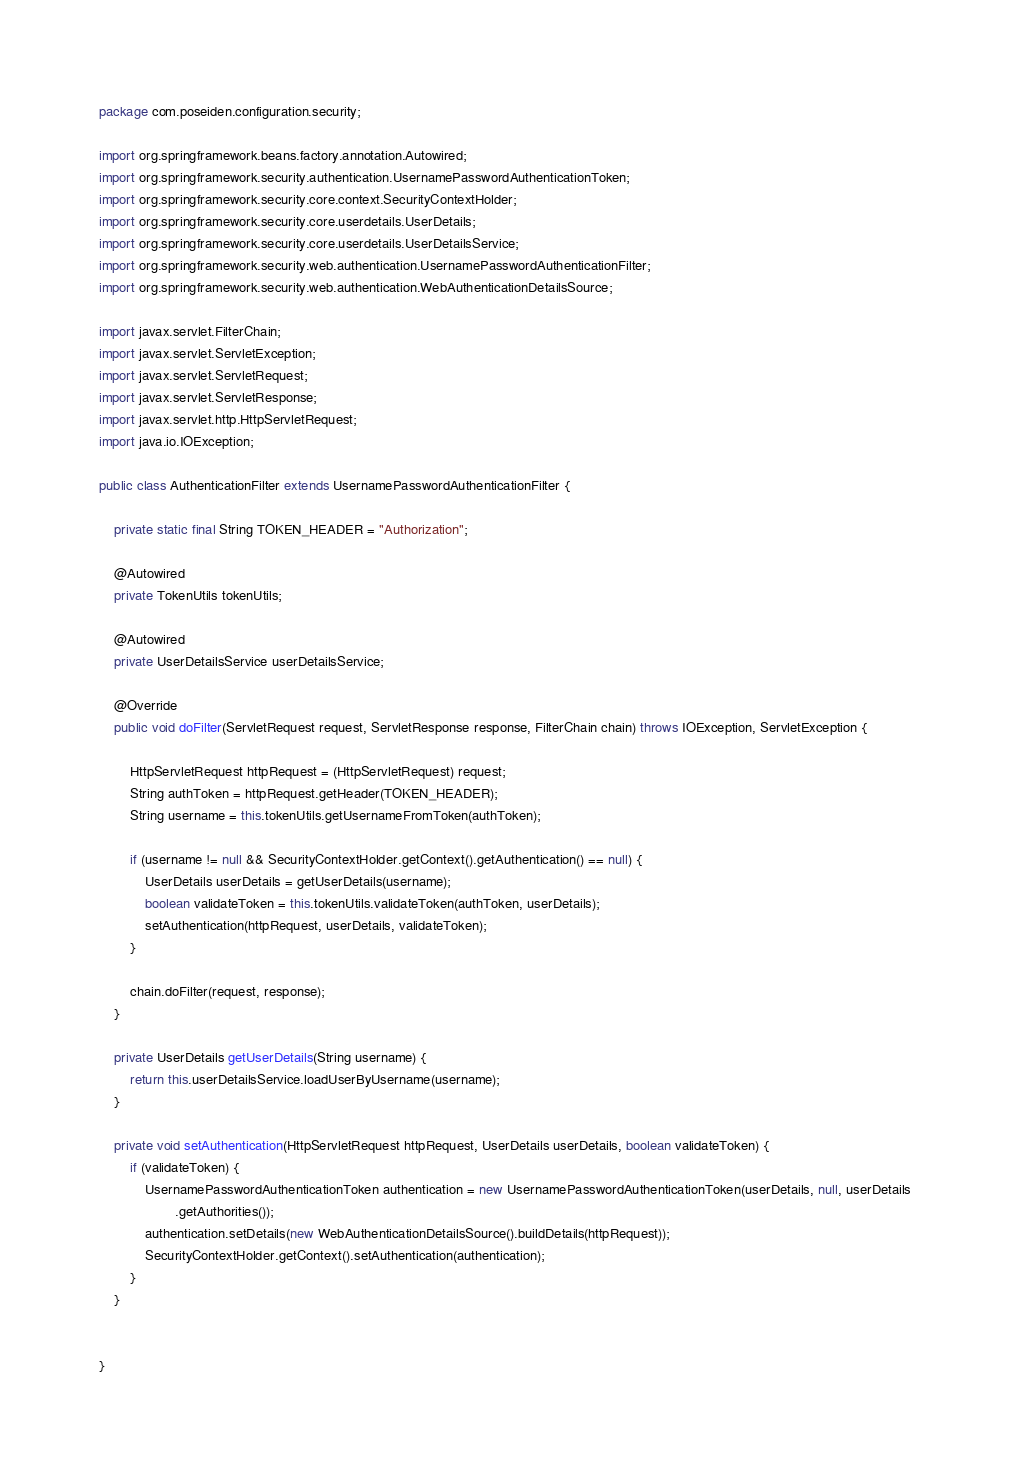<code> <loc_0><loc_0><loc_500><loc_500><_Java_>package com.poseiden.configuration.security;

import org.springframework.beans.factory.annotation.Autowired;
import org.springframework.security.authentication.UsernamePasswordAuthenticationToken;
import org.springframework.security.core.context.SecurityContextHolder;
import org.springframework.security.core.userdetails.UserDetails;
import org.springframework.security.core.userdetails.UserDetailsService;
import org.springframework.security.web.authentication.UsernamePasswordAuthenticationFilter;
import org.springframework.security.web.authentication.WebAuthenticationDetailsSource;

import javax.servlet.FilterChain;
import javax.servlet.ServletException;
import javax.servlet.ServletRequest;
import javax.servlet.ServletResponse;
import javax.servlet.http.HttpServletRequest;
import java.io.IOException;

public class AuthenticationFilter extends UsernamePasswordAuthenticationFilter {

    private static final String TOKEN_HEADER = "Authorization";

    @Autowired
    private TokenUtils tokenUtils;

    @Autowired
    private UserDetailsService userDetailsService;

    @Override
    public void doFilter(ServletRequest request, ServletResponse response, FilterChain chain) throws IOException, ServletException {

        HttpServletRequest httpRequest = (HttpServletRequest) request;
        String authToken = httpRequest.getHeader(TOKEN_HEADER);
        String username = this.tokenUtils.getUsernameFromToken(authToken);

        if (username != null && SecurityContextHolder.getContext().getAuthentication() == null) {
            UserDetails userDetails = getUserDetails(username);
            boolean validateToken = this.tokenUtils.validateToken(authToken, userDetails);
            setAuthentication(httpRequest, userDetails, validateToken);
        }

        chain.doFilter(request, response);
    }

    private UserDetails getUserDetails(String username) {
        return this.userDetailsService.loadUserByUsername(username);
    }

    private void setAuthentication(HttpServletRequest httpRequest, UserDetails userDetails, boolean validateToken) {
        if (validateToken) {
            UsernamePasswordAuthenticationToken authentication = new UsernamePasswordAuthenticationToken(userDetails, null, userDetails
                    .getAuthorities());
            authentication.setDetails(new WebAuthenticationDetailsSource().buildDetails(httpRequest));
            SecurityContextHolder.getContext().setAuthentication(authentication);
        }
    }


}
</code> 